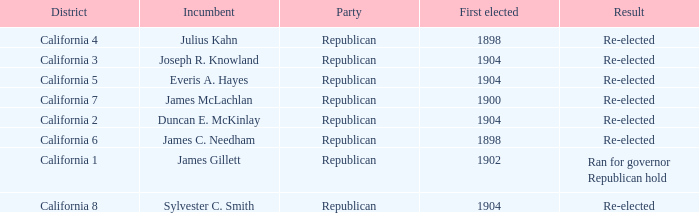Which District has a Result of Re-elected and a First Elected of 1898? California 4, California 6. 